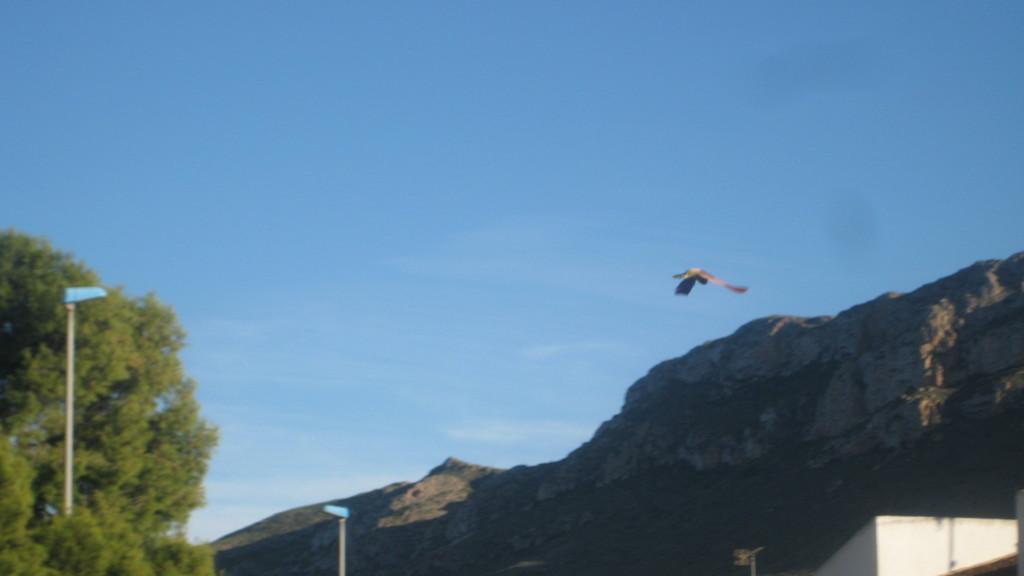In one or two sentences, can you explain what this image depicts? In this image there are trees, lights, poles, a hill, and a bird flying in the sky. 